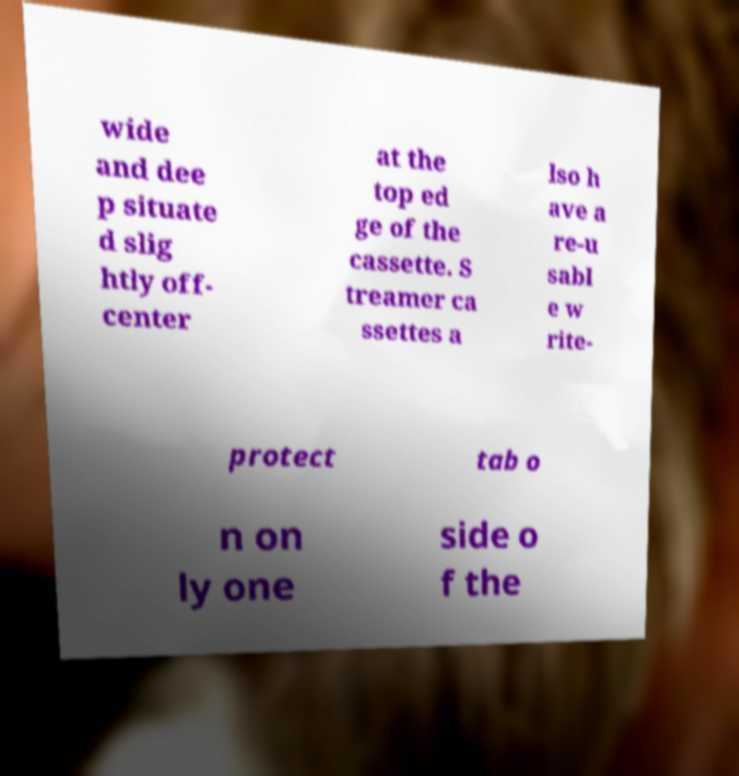Can you read and provide the text displayed in the image?This photo seems to have some interesting text. Can you extract and type it out for me? wide and dee p situate d slig htly off- center at the top ed ge of the cassette. S treamer ca ssettes a lso h ave a re-u sabl e w rite- protect tab o n on ly one side o f the 